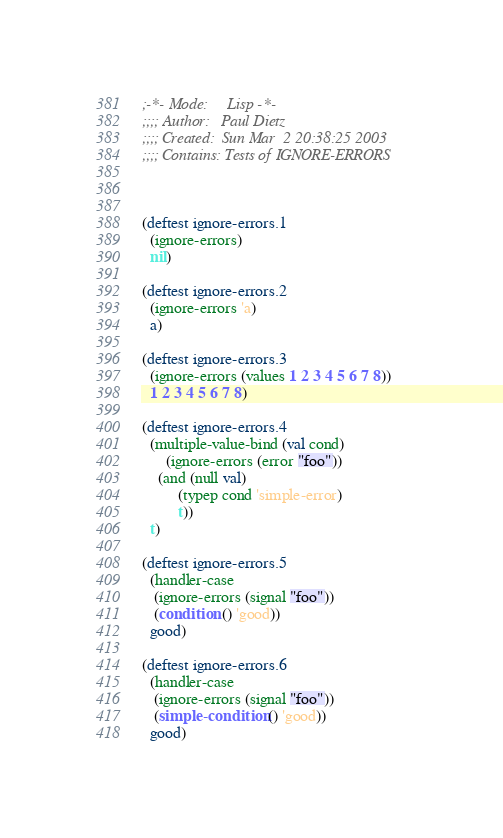<code> <loc_0><loc_0><loc_500><loc_500><_Lisp_>;-*- Mode:     Lisp -*-
;;;; Author:   Paul Dietz
;;;; Created:  Sun Mar  2 20:38:25 2003
;;;; Contains: Tests of IGNORE-ERRORS



(deftest ignore-errors.1
  (ignore-errors)
  nil)

(deftest ignore-errors.2
  (ignore-errors 'a)
  a)

(deftest ignore-errors.3
  (ignore-errors (values 1 2 3 4 5 6 7 8))
  1 2 3 4 5 6 7 8)

(deftest ignore-errors.4
  (multiple-value-bind (val cond)
      (ignore-errors (error "foo"))
    (and (null val)
         (typep cond 'simple-error)
         t))
  t)

(deftest ignore-errors.5
  (handler-case
   (ignore-errors (signal "foo"))
   (condition () 'good))
  good)

(deftest ignore-errors.6
  (handler-case
   (ignore-errors (signal "foo"))
   (simple-condition () 'good))
  good)
</code> 